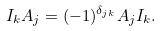Convert formula to latex. <formula><loc_0><loc_0><loc_500><loc_500>I _ { k } A _ { j } = ( - 1 ) ^ { \delta _ { j k } } A _ { j } I _ { k } .</formula> 